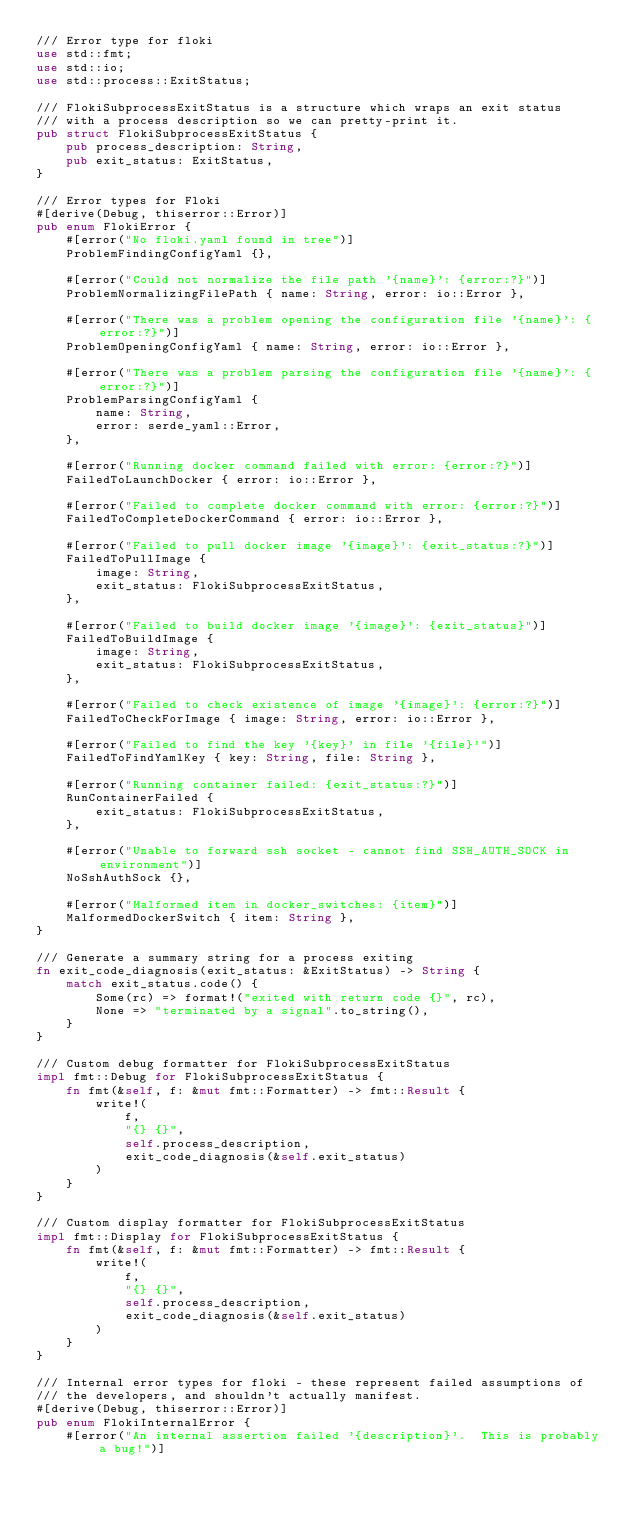Convert code to text. <code><loc_0><loc_0><loc_500><loc_500><_Rust_>/// Error type for floki
use std::fmt;
use std::io;
use std::process::ExitStatus;

/// FlokiSubprocessExitStatus is a structure which wraps an exit status
/// with a process description so we can pretty-print it.
pub struct FlokiSubprocessExitStatus {
    pub process_description: String,
    pub exit_status: ExitStatus,
}

/// Error types for Floki
#[derive(Debug, thiserror::Error)]
pub enum FlokiError {
    #[error("No floki.yaml found in tree")]
    ProblemFindingConfigYaml {},

    #[error("Could not normalize the file path '{name}': {error:?}")]
    ProblemNormalizingFilePath { name: String, error: io::Error },

    #[error("There was a problem opening the configuration file '{name}': {error:?}")]
    ProblemOpeningConfigYaml { name: String, error: io::Error },

    #[error("There was a problem parsing the configuration file '{name}': {error:?}")]
    ProblemParsingConfigYaml {
        name: String,
        error: serde_yaml::Error,
    },

    #[error("Running docker command failed with error: {error:?}")]
    FailedToLaunchDocker { error: io::Error },

    #[error("Failed to complete docker command with error: {error:?}")]
    FailedToCompleteDockerCommand { error: io::Error },

    #[error("Failed to pull docker image '{image}': {exit_status:?}")]
    FailedToPullImage {
        image: String,
        exit_status: FlokiSubprocessExitStatus,
    },

    #[error("Failed to build docker image '{image}': {exit_status}")]
    FailedToBuildImage {
        image: String,
        exit_status: FlokiSubprocessExitStatus,
    },

    #[error("Failed to check existence of image '{image}': {error:?}")]
    FailedToCheckForImage { image: String, error: io::Error },

    #[error("Failed to find the key '{key}' in file '{file}'")]
    FailedToFindYamlKey { key: String, file: String },

    #[error("Running container failed: {exit_status:?}")]
    RunContainerFailed {
        exit_status: FlokiSubprocessExitStatus,
    },

    #[error("Unable to forward ssh socket - cannot find SSH_AUTH_SOCK in environment")]
    NoSshAuthSock {},

    #[error("Malformed item in docker_switches: {item}")]
    MalformedDockerSwitch { item: String },
}

/// Generate a summary string for a process exiting
fn exit_code_diagnosis(exit_status: &ExitStatus) -> String {
    match exit_status.code() {
        Some(rc) => format!("exited with return code {}", rc),
        None => "terminated by a signal".to_string(),
    }
}

/// Custom debug formatter for FlokiSubprocessExitStatus
impl fmt::Debug for FlokiSubprocessExitStatus {
    fn fmt(&self, f: &mut fmt::Formatter) -> fmt::Result {
        write!(
            f,
            "{} {}",
            self.process_description,
            exit_code_diagnosis(&self.exit_status)
        )
    }
}

/// Custom display formatter for FlokiSubprocessExitStatus
impl fmt::Display for FlokiSubprocessExitStatus {
    fn fmt(&self, f: &mut fmt::Formatter) -> fmt::Result {
        write!(
            f,
            "{} {}",
            self.process_description,
            exit_code_diagnosis(&self.exit_status)
        )
    }
}

/// Internal error types for floki - these represent failed assumptions of
/// the developers, and shouldn't actually manifest.
#[derive(Debug, thiserror::Error)]
pub enum FlokiInternalError {
    #[error("An internal assertion failed '{description}'.  This is probably a bug!")]</code> 